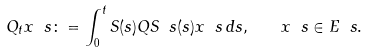<formula> <loc_0><loc_0><loc_500><loc_500>Q _ { t } x \ s \colon = \int ^ { t } _ { 0 } S ( s ) Q S \ s ( s ) x \ s \, d s , \quad x \ s \in E \ s .</formula> 